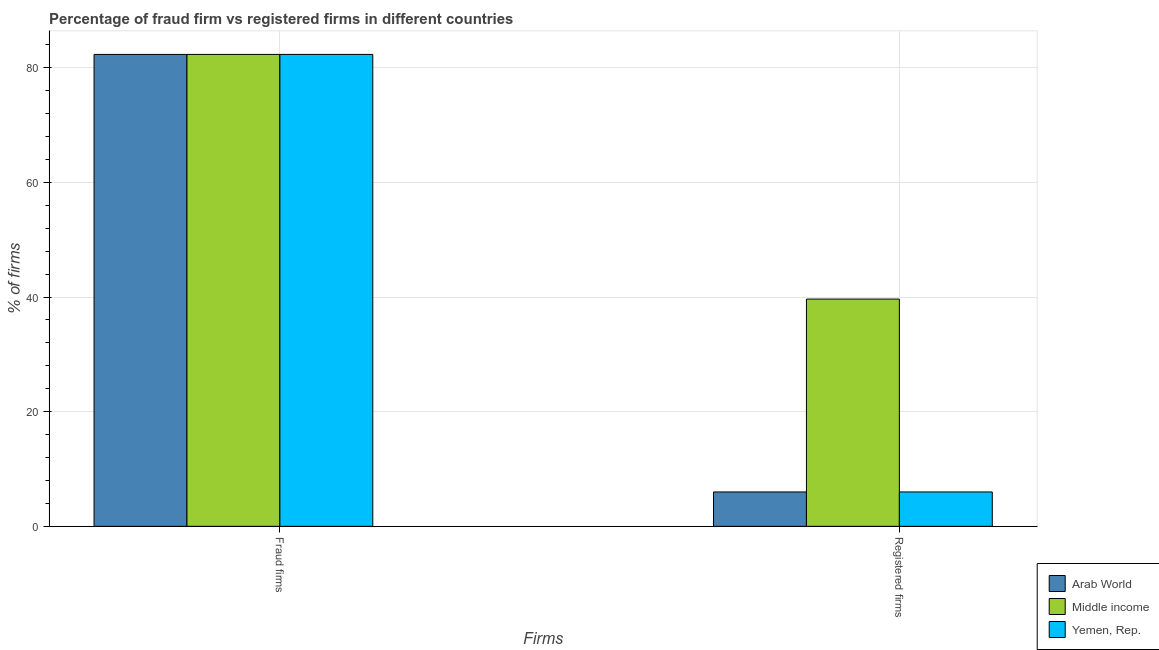How many different coloured bars are there?
Offer a terse response. 3. Are the number of bars per tick equal to the number of legend labels?
Make the answer very short. Yes. What is the label of the 1st group of bars from the left?
Keep it short and to the point. Fraud firms. What is the percentage of fraud firms in Yemen, Rep.?
Make the answer very short. 82.33. Across all countries, what is the maximum percentage of fraud firms?
Your answer should be very brief. 82.33. Across all countries, what is the minimum percentage of registered firms?
Ensure brevity in your answer.  6. In which country was the percentage of fraud firms minimum?
Your answer should be very brief. Arab World. What is the total percentage of registered firms in the graph?
Your answer should be very brief. 51.65. What is the difference between the percentage of registered firms in Yemen, Rep. and the percentage of fraud firms in Middle income?
Keep it short and to the point. -76.33. What is the average percentage of fraud firms per country?
Provide a short and direct response. 82.33. What is the difference between the percentage of fraud firms and percentage of registered firms in Yemen, Rep.?
Offer a very short reply. 76.33. What does the 2nd bar from the left in Fraud firms represents?
Make the answer very short. Middle income. What does the 2nd bar from the right in Registered firms represents?
Provide a succinct answer. Middle income. What is the difference between two consecutive major ticks on the Y-axis?
Keep it short and to the point. 20. Are the values on the major ticks of Y-axis written in scientific E-notation?
Make the answer very short. No. Where does the legend appear in the graph?
Your response must be concise. Bottom right. What is the title of the graph?
Make the answer very short. Percentage of fraud firm vs registered firms in different countries. What is the label or title of the X-axis?
Give a very brief answer. Firms. What is the label or title of the Y-axis?
Offer a very short reply. % of firms. What is the % of firms in Arab World in Fraud firms?
Give a very brief answer. 82.33. What is the % of firms in Middle income in Fraud firms?
Provide a short and direct response. 82.33. What is the % of firms in Yemen, Rep. in Fraud firms?
Give a very brief answer. 82.33. What is the % of firms of Middle income in Registered firms?
Give a very brief answer. 39.65. Across all Firms, what is the maximum % of firms in Arab World?
Offer a very short reply. 82.33. Across all Firms, what is the maximum % of firms of Middle income?
Your answer should be compact. 82.33. Across all Firms, what is the maximum % of firms of Yemen, Rep.?
Make the answer very short. 82.33. Across all Firms, what is the minimum % of firms of Arab World?
Give a very brief answer. 6. Across all Firms, what is the minimum % of firms of Middle income?
Ensure brevity in your answer.  39.65. What is the total % of firms in Arab World in the graph?
Keep it short and to the point. 88.33. What is the total % of firms in Middle income in the graph?
Your response must be concise. 121.98. What is the total % of firms in Yemen, Rep. in the graph?
Make the answer very short. 88.33. What is the difference between the % of firms of Arab World in Fraud firms and that in Registered firms?
Offer a terse response. 76.33. What is the difference between the % of firms in Middle income in Fraud firms and that in Registered firms?
Ensure brevity in your answer.  42.68. What is the difference between the % of firms of Yemen, Rep. in Fraud firms and that in Registered firms?
Your answer should be compact. 76.33. What is the difference between the % of firms of Arab World in Fraud firms and the % of firms of Middle income in Registered firms?
Ensure brevity in your answer.  42.68. What is the difference between the % of firms of Arab World in Fraud firms and the % of firms of Yemen, Rep. in Registered firms?
Ensure brevity in your answer.  76.33. What is the difference between the % of firms of Middle income in Fraud firms and the % of firms of Yemen, Rep. in Registered firms?
Keep it short and to the point. 76.33. What is the average % of firms in Arab World per Firms?
Give a very brief answer. 44.16. What is the average % of firms of Middle income per Firms?
Offer a terse response. 60.99. What is the average % of firms in Yemen, Rep. per Firms?
Your answer should be very brief. 44.16. What is the difference between the % of firms in Arab World and % of firms in Middle income in Fraud firms?
Keep it short and to the point. 0. What is the difference between the % of firms in Middle income and % of firms in Yemen, Rep. in Fraud firms?
Make the answer very short. 0. What is the difference between the % of firms in Arab World and % of firms in Middle income in Registered firms?
Give a very brief answer. -33.65. What is the difference between the % of firms in Middle income and % of firms in Yemen, Rep. in Registered firms?
Your response must be concise. 33.65. What is the ratio of the % of firms in Arab World in Fraud firms to that in Registered firms?
Provide a succinct answer. 13.72. What is the ratio of the % of firms in Middle income in Fraud firms to that in Registered firms?
Offer a terse response. 2.08. What is the ratio of the % of firms of Yemen, Rep. in Fraud firms to that in Registered firms?
Provide a succinct answer. 13.72. What is the difference between the highest and the second highest % of firms of Arab World?
Ensure brevity in your answer.  76.33. What is the difference between the highest and the second highest % of firms of Middle income?
Keep it short and to the point. 42.68. What is the difference between the highest and the second highest % of firms in Yemen, Rep.?
Provide a succinct answer. 76.33. What is the difference between the highest and the lowest % of firms in Arab World?
Your answer should be very brief. 76.33. What is the difference between the highest and the lowest % of firms in Middle income?
Ensure brevity in your answer.  42.68. What is the difference between the highest and the lowest % of firms in Yemen, Rep.?
Your answer should be very brief. 76.33. 